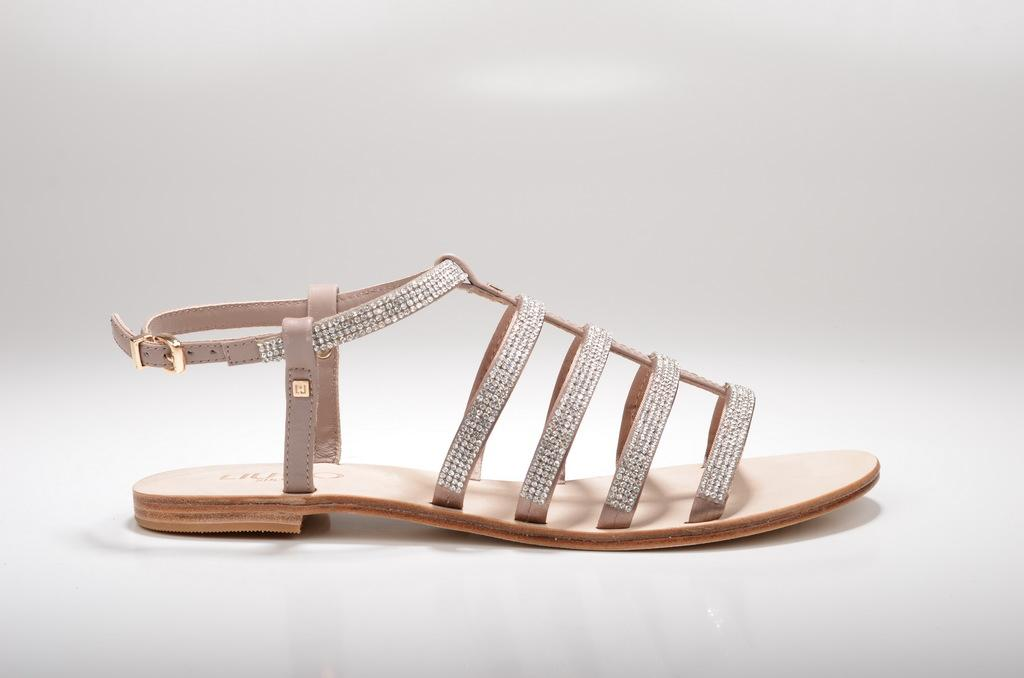What type of footwear is visible in the image? There is a sandal in the image. What color is the background of the image? The background of the image is white. How many jellyfish can be seen swimming in the image? There are no jellyfish present in the image; it only features a sandal and a white background. 